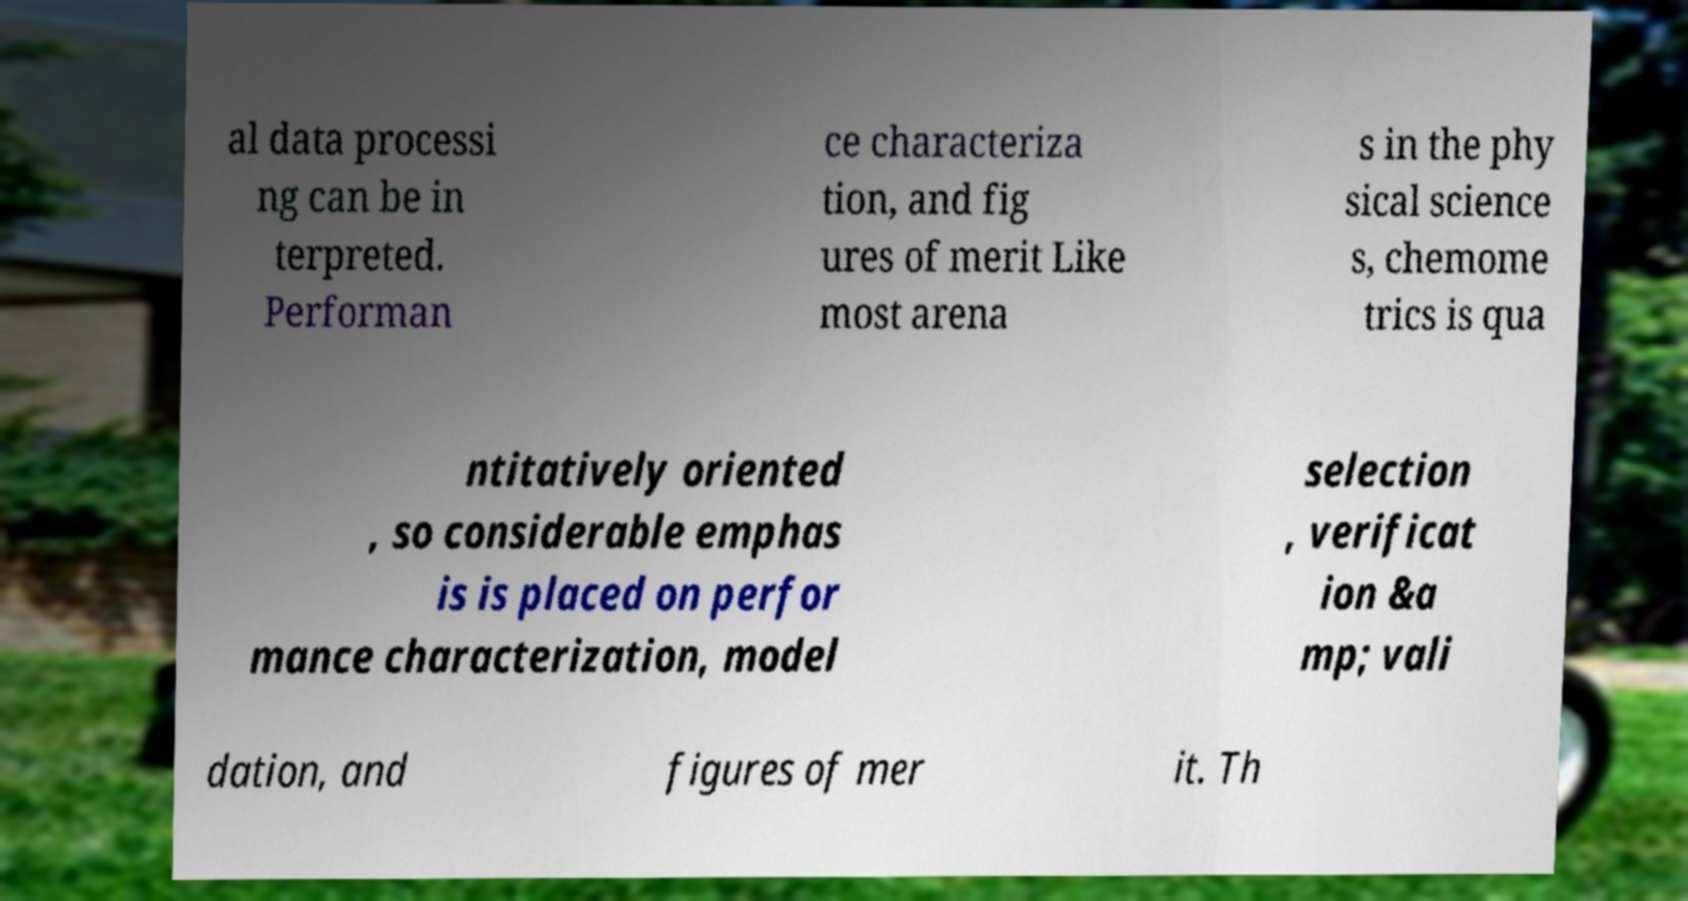Can you read and provide the text displayed in the image?This photo seems to have some interesting text. Can you extract and type it out for me? al data processi ng can be in terpreted. Performan ce characteriza tion, and fig ures of merit Like most arena s in the phy sical science s, chemome trics is qua ntitatively oriented , so considerable emphas is is placed on perfor mance characterization, model selection , verificat ion &a mp; vali dation, and figures of mer it. Th 